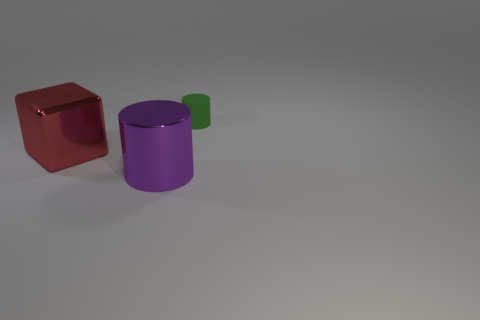How many red blocks are the same material as the big purple thing?
Give a very brief answer. 1. Is there a red metal block?
Offer a terse response. Yes. Is the small green thing made of the same material as the big thing in front of the cube?
Make the answer very short. No. Is the number of large metal blocks that are to the left of the rubber cylinder greater than the number of large gray metal spheres?
Your answer should be compact. Yes. Is there any other thing that has the same size as the red thing?
Offer a very short reply. Yes. Do the metal block and the object that is in front of the big block have the same color?
Your answer should be very brief. No. Is the number of green objects left of the large red metal cube the same as the number of green rubber cylinders that are to the left of the purple object?
Provide a succinct answer. Yes. There is a cylinder on the left side of the tiny rubber cylinder; what is it made of?
Your response must be concise. Metal. How many objects are either cylinders in front of the rubber cylinder or large gray objects?
Keep it short and to the point. 1. What number of other objects are the same shape as the tiny green matte thing?
Give a very brief answer. 1. 